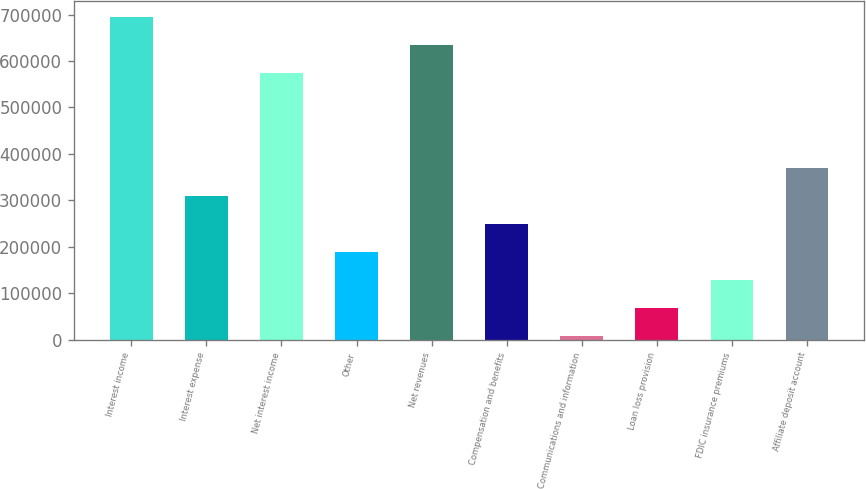Convert chart to OTSL. <chart><loc_0><loc_0><loc_500><loc_500><bar_chart><fcel>Interest income<fcel>Interest expense<fcel>Net interest income<fcel>Other<fcel>Net revenues<fcel>Compensation and benefits<fcel>Communications and information<fcel>Loan loss provision<fcel>FDIC insurance premiums<fcel>Affiliate deposit account<nl><fcel>695201<fcel>308958<fcel>574796<fcel>188554<fcel>634998<fcel>248756<fcel>7946<fcel>68148.5<fcel>128351<fcel>369161<nl></chart> 